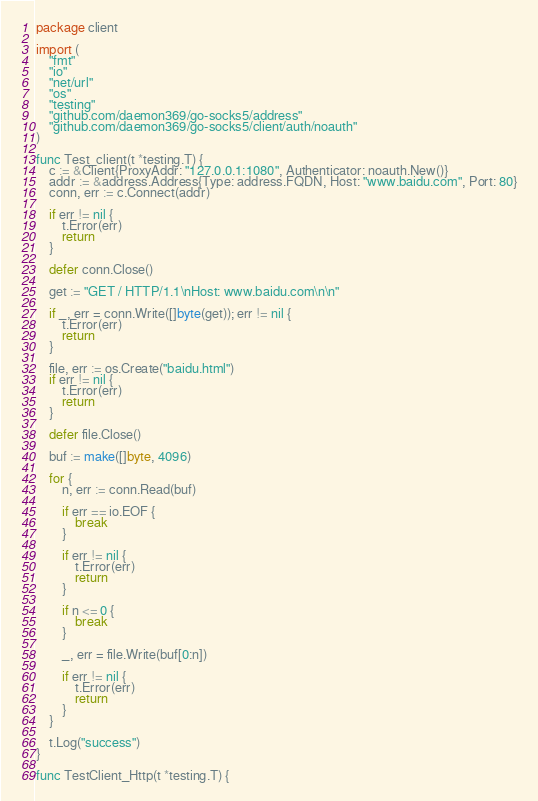<code> <loc_0><loc_0><loc_500><loc_500><_Go_>package client

import (
	"fmt"
	"io"
	"net/url"
	"os"
	"testing"
	"github.com/daemon369/go-socks5/address"
	"github.com/daemon369/go-socks5/client/auth/noauth"
)

func Test_client(t *testing.T) {
	c := &Client{ProxyAddr: "127.0.0.1:1080", Authenticator: noauth.New()}
	addr := &address.Address{Type: address.FQDN, Host: "www.baidu.com", Port: 80}
	conn, err := c.Connect(addr)

	if err != nil {
		t.Error(err)
		return
	}

	defer conn.Close()

	get := "GET / HTTP/1.1\nHost: www.baidu.com\n\n"

	if _, err = conn.Write([]byte(get)); err != nil {
		t.Error(err)
		return
	}

	file, err := os.Create("baidu.html")
	if err != nil {
		t.Error(err)
		return
	}

	defer file.Close()

	buf := make([]byte, 4096)

	for {
		n, err := conn.Read(buf)

		if err == io.EOF {
			break
		}

		if err != nil {
			t.Error(err)
			return
		}

		if n <= 0 {
			break
		}

		_, err = file.Write(buf[0:n])

		if err != nil {
			t.Error(err)
			return
		}
	}

	t.Log("success")
}

func TestClient_Http(t *testing.T) {</code> 